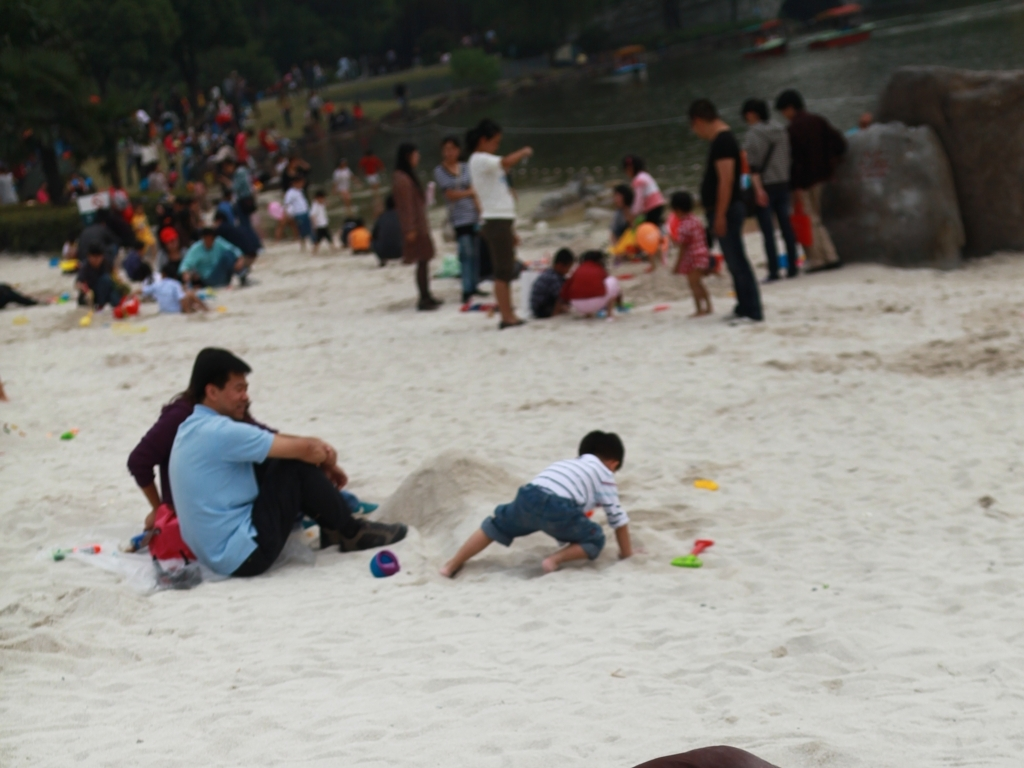How is the weather in the image? The lighting in the image is not very bright, suggesting an overcast sky. However, the people in the image are not wearing heavy clothing or protection from rain, indicating that the weather is likely mild and comfortable. 